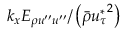Convert formula to latex. <formula><loc_0><loc_0><loc_500><loc_500>k _ { x } E _ { \rho u ^ { \prime \prime } u ^ { \prime \prime } } / \left ( \bar { \rho } { u _ { \tau } ^ { * } } ^ { 2 } \right )</formula> 